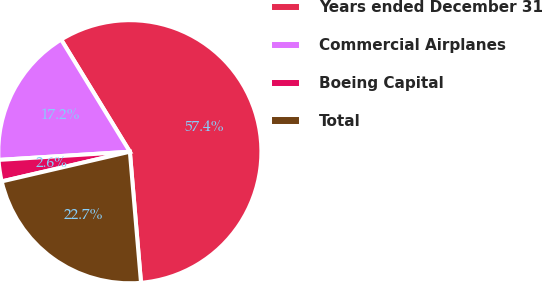<chart> <loc_0><loc_0><loc_500><loc_500><pie_chart><fcel>Years ended December 31<fcel>Commercial Airplanes<fcel>Boeing Capital<fcel>Total<nl><fcel>57.4%<fcel>17.25%<fcel>2.63%<fcel>22.73%<nl></chart> 